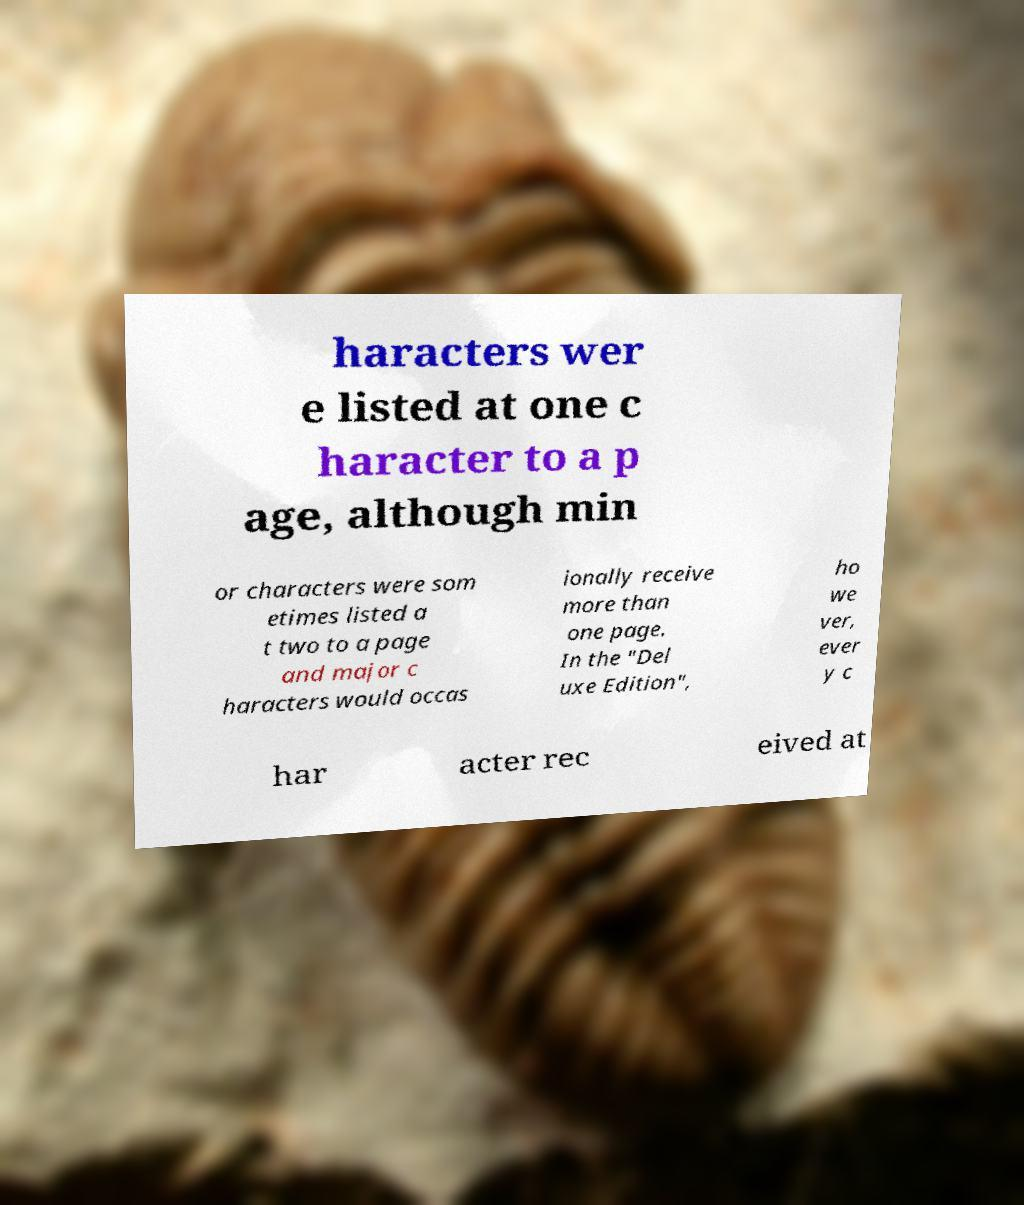Can you accurately transcribe the text from the provided image for me? haracters wer e listed at one c haracter to a p age, although min or characters were som etimes listed a t two to a page and major c haracters would occas ionally receive more than one page. In the "Del uxe Edition", ho we ver, ever y c har acter rec eived at 